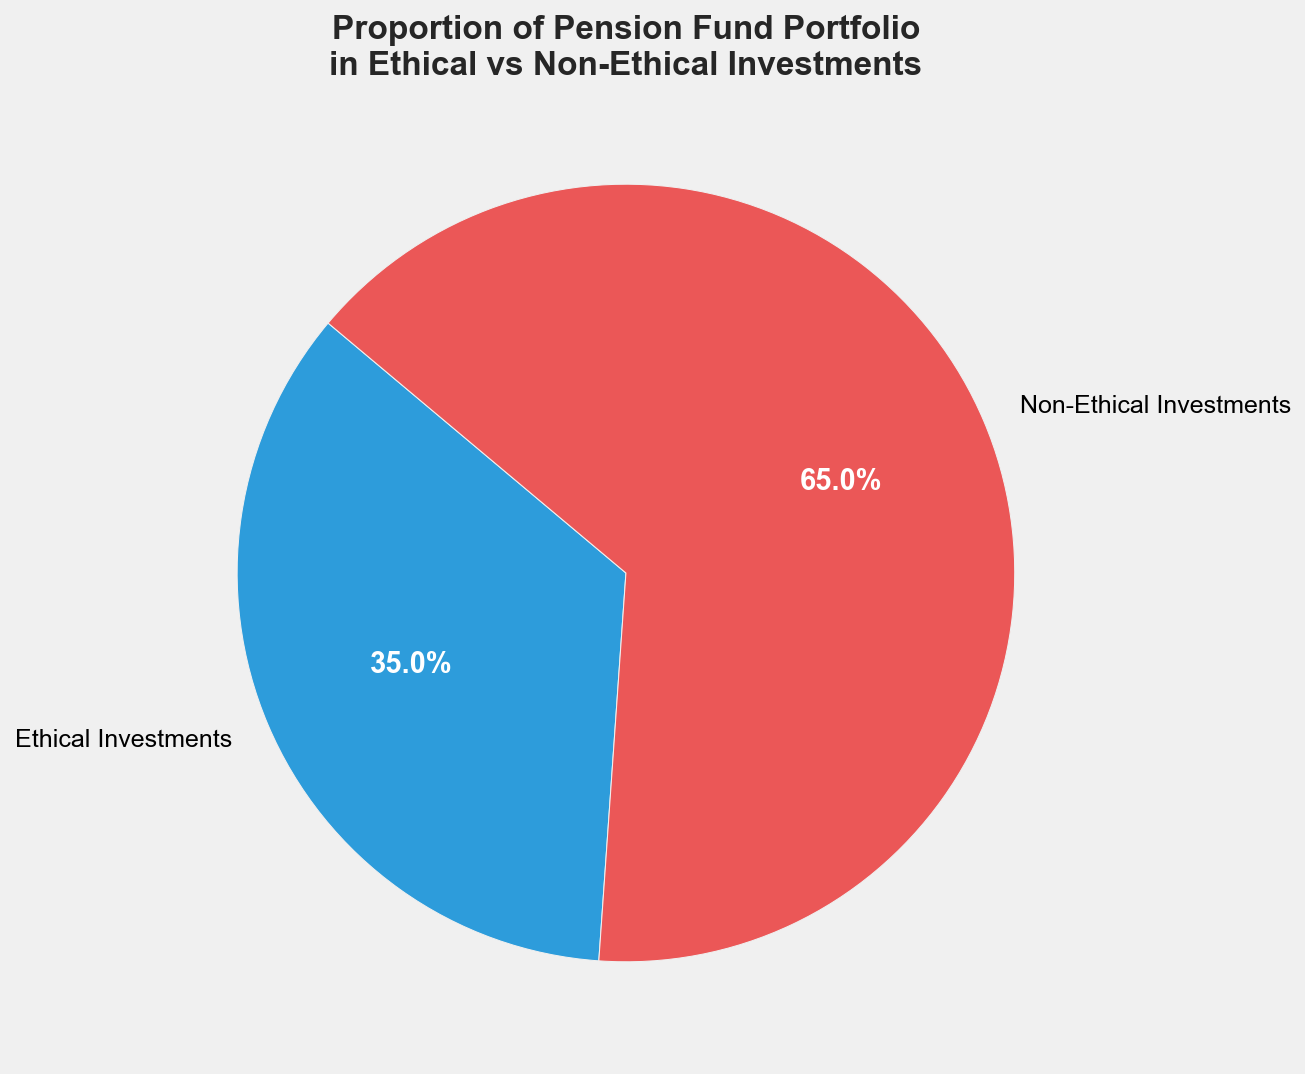Which category has a higher proportion in the pension fund portfolio? By observing the pie chart, the segment labeled "Non-Ethical Investments" is larger than the one labeled "Ethical Investments."
Answer: Non-Ethical Investments What percentage of the pension fund portfolio is allocated to ethical investments? The pie chart shows the proportion for "Ethical Investments" with a numerical label inside or near the respective segment.
Answer: 35% By how many percentage points do non-ethical investments exceed ethical investments? Subtract the percentage value of "Ethical Investments" (35%) from "Non-Ethical Investments" (65%). Calculation: 65% - 35% = 30%
Answer: 30% What is the combined percentage of ethical and non-ethical investments? Sum the percentage values of "Ethical Investments" and "Non-Ethical Investments." Calculation: 35% + 65% = 100%
Answer: 100% If the pension fund redistributes 10% of non-ethical investments to ethical investments, what would the new proportions be? Subtract 10% from the "Non-Ethical Investments" and add it to the "Ethical Investments". New Ethical Investments = 35% + 10% = 45%, new Non-Ethical Investments = 65% - 10% = 55%
Answer: Ethical Investments: 45%, Non-Ethical Investments: 55% Which investment category is highlighted with a red segment? The visual attribute of color in the pie chart indicates that "Non-Ethical Investments" is highlighted in red.
Answer: Non-Ethical Investments Is the proportion of ethical investments less than half of the total portfolio? Compare the percentage of "Ethical Investments" (35%) to 50%. Since 35% is less than 50%, it is less than half of the total portfolio.
Answer: Yes Is the difference between the proportions of ethical and non-ethical investments more than 25%? Calculate the difference: 65% - 35% = 30%. Since 30% > 25%, the difference is more than 25%.
Answer: Yes What would the average proportion be if both categories were equally distributed? If evenly distributed, both categories would have the same proportion. This can be calculated by dividing 100% by 2. Calculation: 100% / 2 = 50%
Answer: 50% Which segment is a lighter shade of color in the pie chart? The visual attribute of shade in the pie chart shows that "Ethical Investments" is a lighter shade of blue compared to the red of "Non-Ethical Investments".
Answer: Ethical Investments 